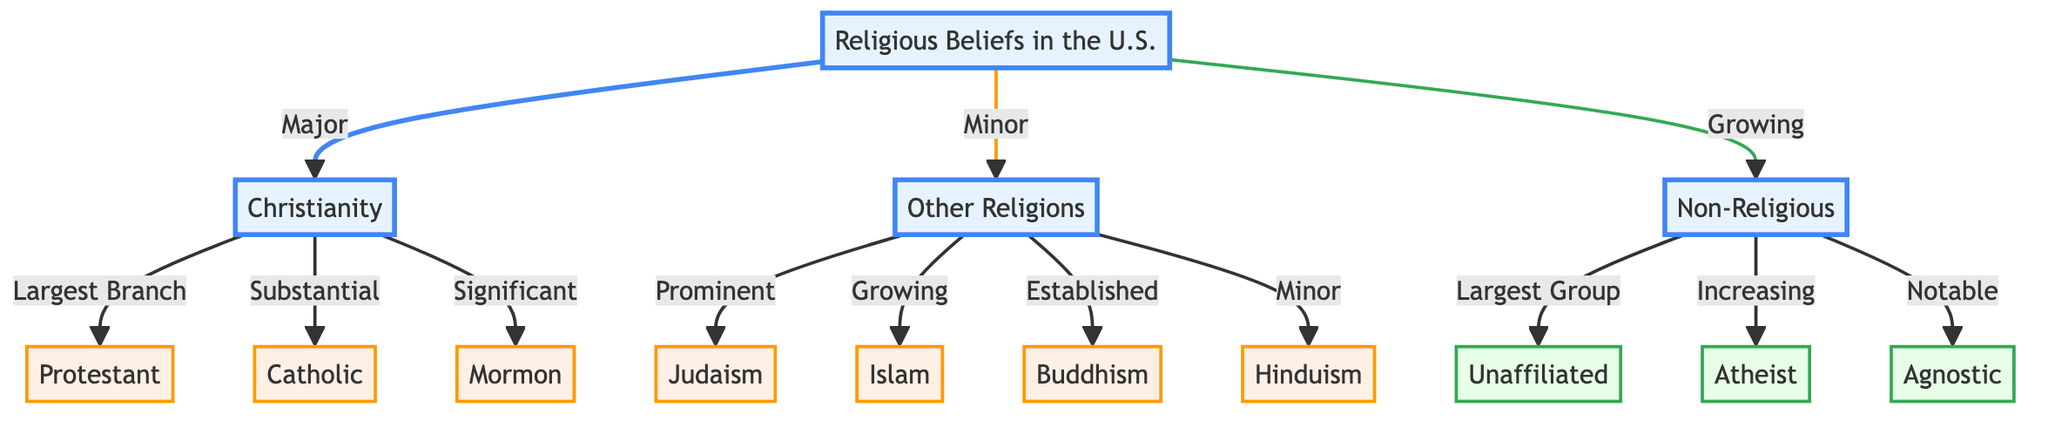What is the largest group identified in the diagram? The diagram indicates that the "Unaffiliated" group is the largest within the "Non-Religious" category, as mentioned in the respective node.
Answer: Unaffiliated Which major religious category is depicted as the largest branch? The diagram specifies that within Christianity, "Protestant" is the largest branch, as denoted by the connection from Christianity.
Answer: Protestant How many minor religious groups are listed in the diagram? The diagram categorizes "Other Religions" into six minor groups: Judaism, Islam, Buddhism, Hinduism. Counting these gives us six.
Answer: 6 What connection is labeled as "Increasing"? The diagram explicitly states that the connection from "Non-Religious" to "Atheist" is labeled as "Increasing".
Answer: Atheist Which group is noted as "Prominent" among the other religions? The diagram indicates that "Judaism" is described as "Prominent" within the "Other Religions" category, as shown by the edge linking them.
Answer: Judaism What is the relationship between "Christianity" and "Catholic"? The diagram shows that "Catholic" is a "Substantial" subgroup of "Christianity". This relationship indicates that while Catholicism is notable, it's not the largest group within Christianity.
Answer: Substantial What color represents the major categories in the diagram? The diagram uses a light blue color to signify the major categories, specifically for the nodes "Religious Beliefs in the U.S.", "Christianity", "Other Religions", and "Non-Religious".
Answer: Light blue Which religious group is identified as "Growing"? The diagram specifically links "Islam" and "Non-Religious" to the label "Growing", indicating an upward trend in those populations or beliefs.
Answer: Islam Which node is not a major religious category in this diagram? The "Unaffiliated" group falls under the "Non-Religious" category, which is labeled as "Growing" but not as "Major". This distinction is crucial when identifying major categories.
Answer: Unaffiliated 